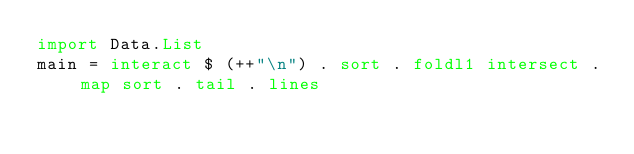<code> <loc_0><loc_0><loc_500><loc_500><_Haskell_>import Data.List
main = interact $ (++"\n") . sort . foldl1 intersect . map sort . tail . lines
</code> 